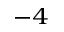<formula> <loc_0><loc_0><loc_500><loc_500>^ { - 4 }</formula> 